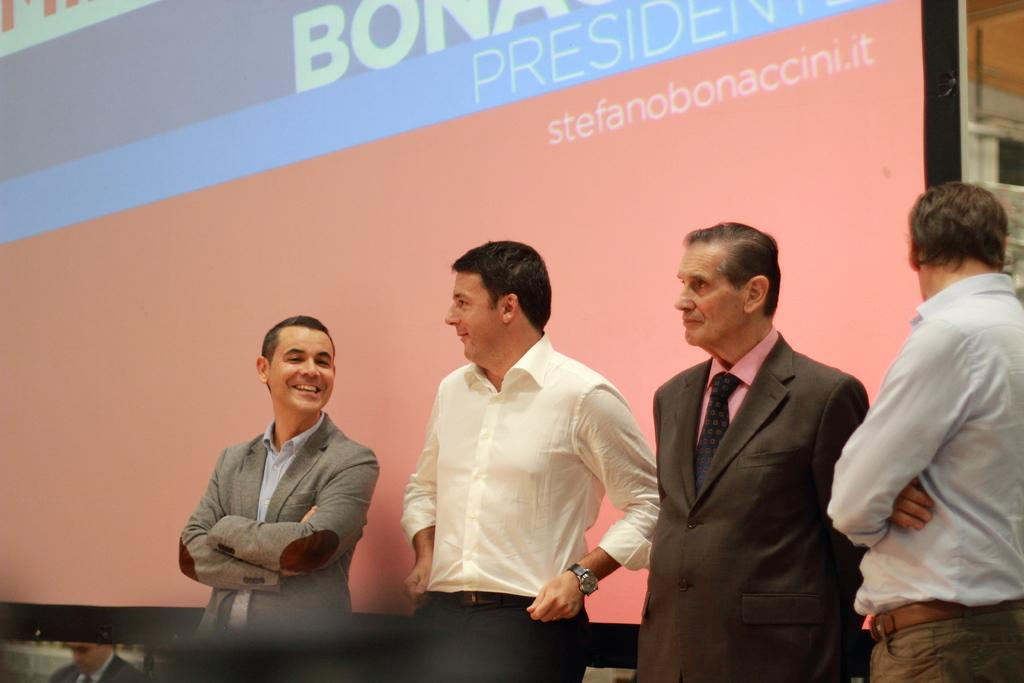What is the primary subject of the image? The primary subject of the image is men standing. What can be seen in the background of the image? There is a screen with text in the background. Can you describe the positioning of the men in relation to the screen? There is a man below the screen, while others are standing in the image. What type of rice is being cooked in the garden in the image? There is no rice or garden present in the image; it features men standing and a screen with text in the background. 